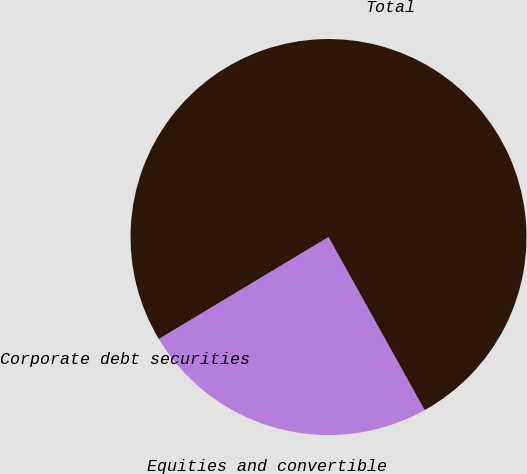Convert chart to OTSL. <chart><loc_0><loc_0><loc_500><loc_500><pie_chart><fcel>Corporate debt securities<fcel>Equities and convertible<fcel>Total<nl><fcel>0.01%<fcel>24.45%<fcel>75.54%<nl></chart> 